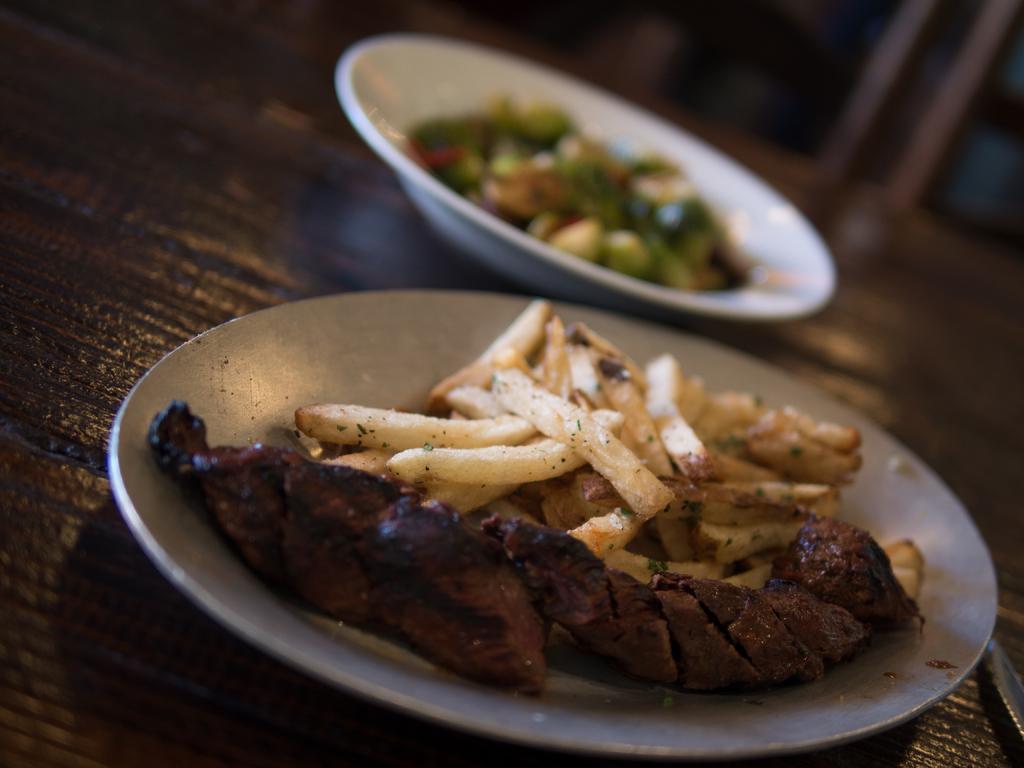Can you describe this image briefly? In this image there are some food items kept in a white color bowl in the bottom of this image and on the top of this image as well. These bowls are kept on a surface which is in the background. 